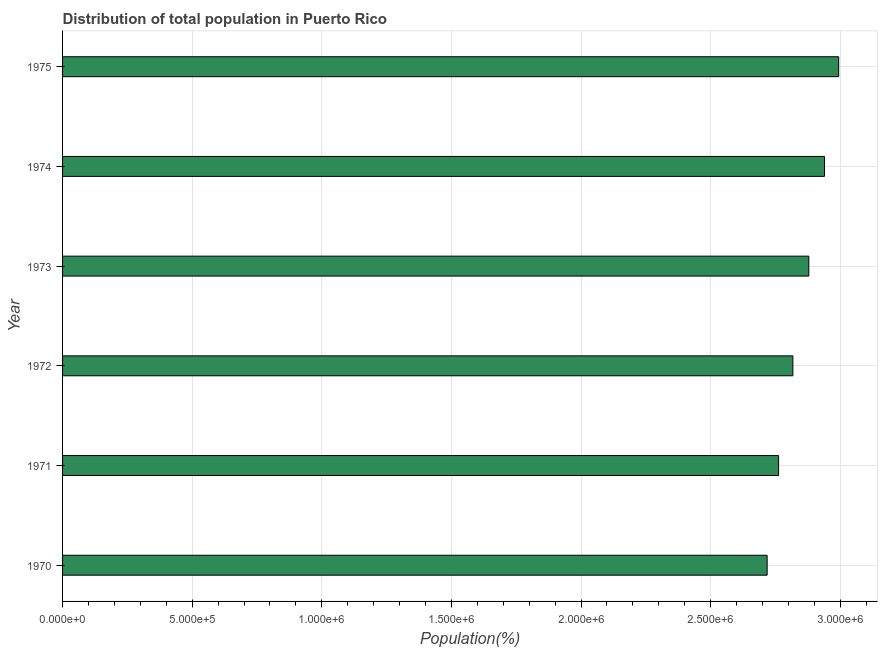Does the graph contain any zero values?
Provide a succinct answer. No. What is the title of the graph?
Make the answer very short. Distribution of total population in Puerto Rico . What is the label or title of the X-axis?
Make the answer very short. Population(%). What is the population in 1972?
Your response must be concise. 2.82e+06. Across all years, what is the maximum population?
Provide a short and direct response. 2.99e+06. Across all years, what is the minimum population?
Give a very brief answer. 2.72e+06. In which year was the population maximum?
Make the answer very short. 1975. In which year was the population minimum?
Your answer should be compact. 1970. What is the sum of the population?
Your answer should be compact. 1.71e+07. What is the difference between the population in 1972 and 1974?
Offer a very short reply. -1.22e+05. What is the average population per year?
Provide a succinct answer. 2.85e+06. What is the median population?
Your response must be concise. 2.85e+06. What is the ratio of the population in 1972 to that in 1975?
Give a very brief answer. 0.94. Is the population in 1974 less than that in 1975?
Provide a succinct answer. Yes. What is the difference between the highest and the second highest population?
Give a very brief answer. 5.47e+04. What is the difference between the highest and the lowest population?
Give a very brief answer. 2.76e+05. In how many years, is the population greater than the average population taken over all years?
Your answer should be very brief. 3. Are all the bars in the graph horizontal?
Your answer should be compact. Yes. What is the difference between two consecutive major ticks on the X-axis?
Offer a very short reply. 5.00e+05. Are the values on the major ticks of X-axis written in scientific E-notation?
Give a very brief answer. Yes. What is the Population(%) of 1970?
Provide a succinct answer. 2.72e+06. What is the Population(%) of 1971?
Offer a terse response. 2.76e+06. What is the Population(%) in 1972?
Your answer should be compact. 2.82e+06. What is the Population(%) of 1973?
Provide a succinct answer. 2.88e+06. What is the Population(%) of 1974?
Offer a very short reply. 2.94e+06. What is the Population(%) of 1975?
Your answer should be very brief. 2.99e+06. What is the difference between the Population(%) in 1970 and 1971?
Keep it short and to the point. -4.42e+04. What is the difference between the Population(%) in 1970 and 1972?
Keep it short and to the point. -9.93e+04. What is the difference between the Population(%) in 1970 and 1973?
Provide a succinct answer. -1.61e+05. What is the difference between the Population(%) in 1970 and 1974?
Offer a very short reply. -2.21e+05. What is the difference between the Population(%) in 1970 and 1975?
Keep it short and to the point. -2.76e+05. What is the difference between the Population(%) in 1971 and 1972?
Offer a very short reply. -5.51e+04. What is the difference between the Population(%) in 1971 and 1973?
Offer a terse response. -1.17e+05. What is the difference between the Population(%) in 1971 and 1974?
Keep it short and to the point. -1.77e+05. What is the difference between the Population(%) in 1971 and 1975?
Your answer should be very brief. -2.32e+05. What is the difference between the Population(%) in 1972 and 1973?
Your answer should be compact. -6.15e+04. What is the difference between the Population(%) in 1972 and 1974?
Keep it short and to the point. -1.22e+05. What is the difference between the Population(%) in 1972 and 1975?
Keep it short and to the point. -1.77e+05. What is the difference between the Population(%) in 1973 and 1974?
Provide a short and direct response. -6.05e+04. What is the difference between the Population(%) in 1973 and 1975?
Provide a succinct answer. -1.15e+05. What is the difference between the Population(%) in 1974 and 1975?
Give a very brief answer. -5.47e+04. What is the ratio of the Population(%) in 1970 to that in 1971?
Keep it short and to the point. 0.98. What is the ratio of the Population(%) in 1970 to that in 1972?
Your response must be concise. 0.96. What is the ratio of the Population(%) in 1970 to that in 1973?
Ensure brevity in your answer.  0.94. What is the ratio of the Population(%) in 1970 to that in 1974?
Ensure brevity in your answer.  0.93. What is the ratio of the Population(%) in 1970 to that in 1975?
Your answer should be compact. 0.91. What is the ratio of the Population(%) in 1971 to that in 1975?
Your response must be concise. 0.92. What is the ratio of the Population(%) in 1972 to that in 1973?
Give a very brief answer. 0.98. What is the ratio of the Population(%) in 1972 to that in 1974?
Your response must be concise. 0.96. What is the ratio of the Population(%) in 1972 to that in 1975?
Make the answer very short. 0.94. 